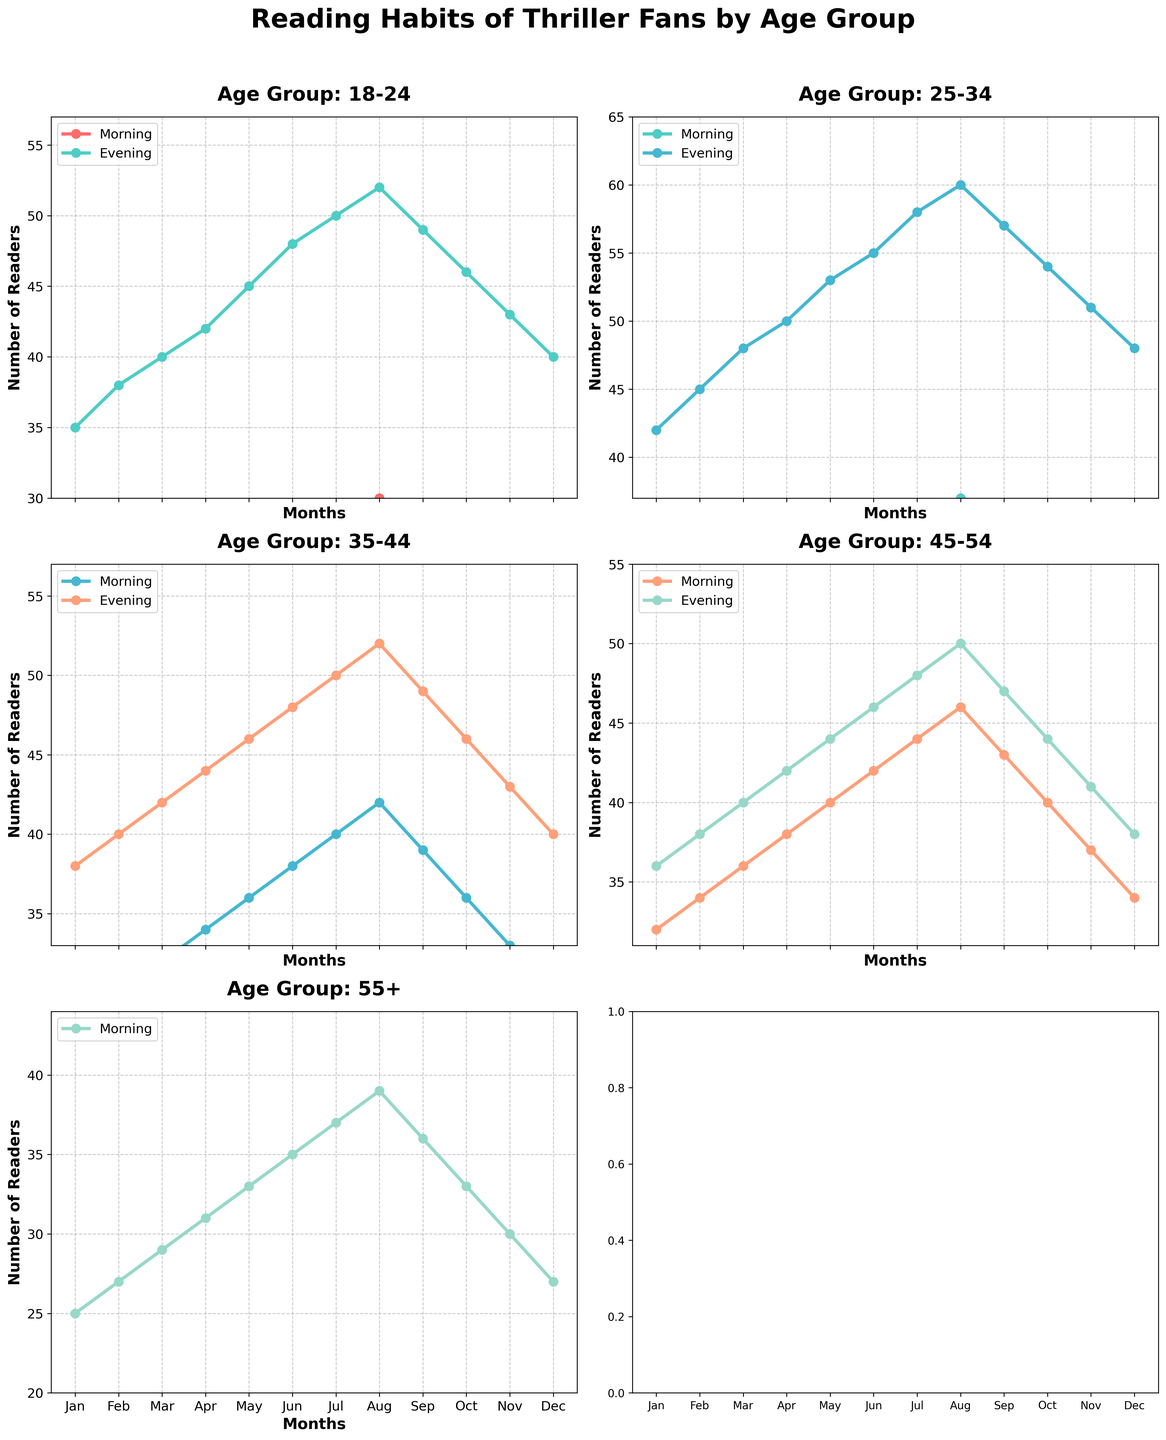How many age groups are represented in the figure? There are five distinct age groups in the figure: 18-24, 25-34, 35-44, 45-54, and 55+.
Answer: Five Which age group has the highest number of readers in the evening during July? The 25-34 age group has the highest number of readers in the evening during July, showing 60 readers as indicated by the top line in July.
Answer: 25-34 Is the number of readers in the morning generally increasing or decreasing for the 45-54 age group throughout the year? For the 45-54 age group, the number of morning readers generally increases from January to August and then decreases from August to December.
Answer: Generally increasing, then decreasing What is the difference in the number of evening readers between January and December for the 18-24 age group? The number of evening readers in January is 35 and in December is 40, so the difference is 40 - 35.
Answer: 5 Which age group shows the smallest range in their morning reading habits, and what is that range? The 18-24 age group shows the smallest range in the morning reading habits, with the number of readers ranging from 15 in January to 30 in August. The range calculation is 30 - 15.
Answer: 18-24, 15 How does the number of evening readers for the 35-44 age group in February compare to the same group in November? For the 35-44 age group, the number of evening readers in February is 40 and in November is 43, showing an increase from 40 to 43.
Answer: Increase from 40 to 43 What is the average number of morning readers for the 55+ age group? Summing the morning readers for the 55+ age group across all months (25 + 27 + 29 + 31 + 33 + 35 + 37 + 39 + 36 + 33 + 30 + 27) gives 382. Dividing by 12 (months) provides the average.
Answer: 31.83 Which age group has a more consistent number of evening readers throughout the year, 35-44 or 45-54? By examining the graph, both age groups have relatively stable numbers, but the 45-54 age group's evening readers (ranging from 36 to 50) are slightly more consistent than the 35-44 age group's (ranging from 38 to 52).
Answer: 45-54 What can be inferred about the reading habits of the 25-34 age group from January to December for both morning and evening time slots? For the 25-34 age group, the number of morning readers generally increases steadily from 22 to 37 and then slightly decreases to 25. Evening readers also increase from 42 to 60 by July and decrease to 48 by December. This shows a rise in readers until mid-year then a decline.
Answer: Increase until mid-year, then decline 